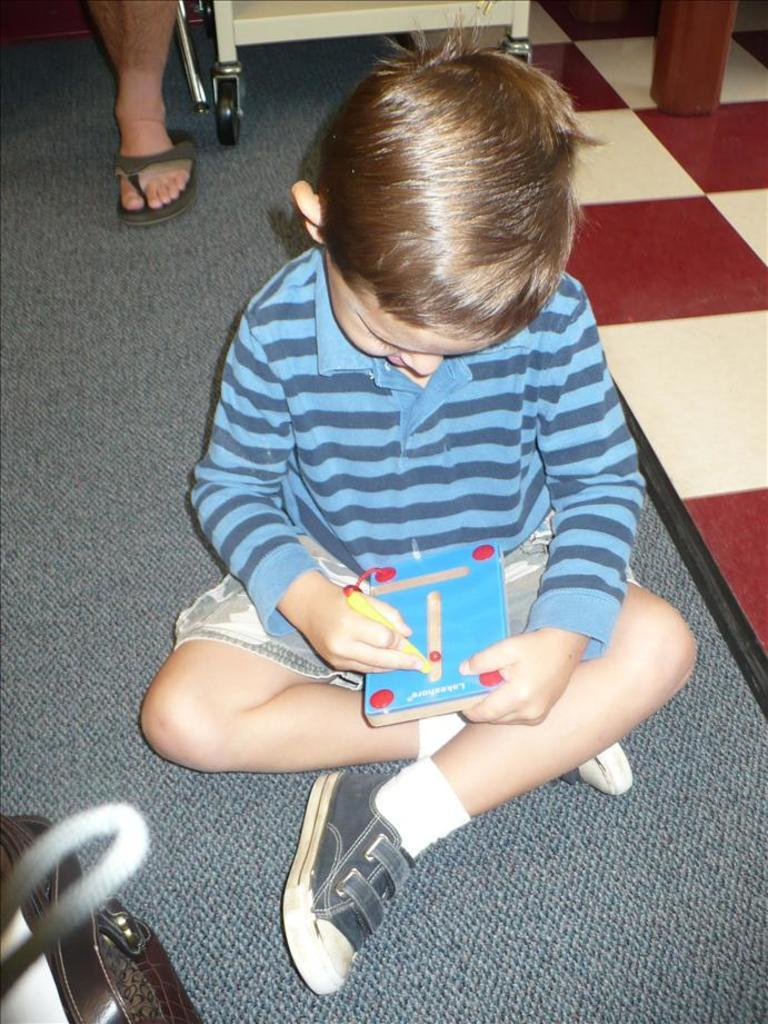What is the boy in the image doing? The boy is sitting in the image. What is the boy holding in the image? The boy is holding a book. Can you describe the background of the image? There is a leg of a person visible in the background of the image. What type of surface is the boy sitting on? There is a floor in the image. Can you tell me how deep the lake is in the image? There is no lake present in the image. What type of knowledge is the boy acquiring from the book in the image? The image does not provide information about the content of the book or the knowledge the boy might be acquiring from it. 